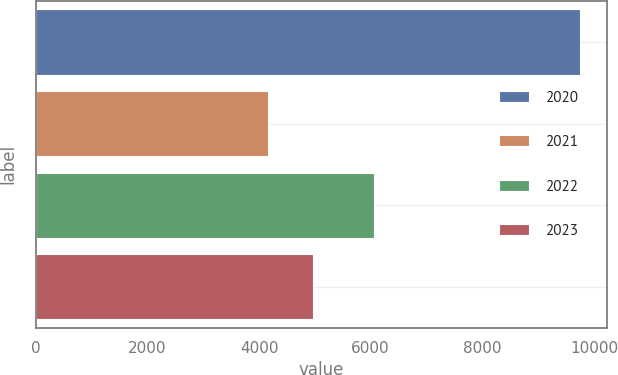<chart> <loc_0><loc_0><loc_500><loc_500><bar_chart><fcel>2020<fcel>2021<fcel>2022<fcel>2023<nl><fcel>9744<fcel>4162<fcel>6067<fcel>4958<nl></chart> 